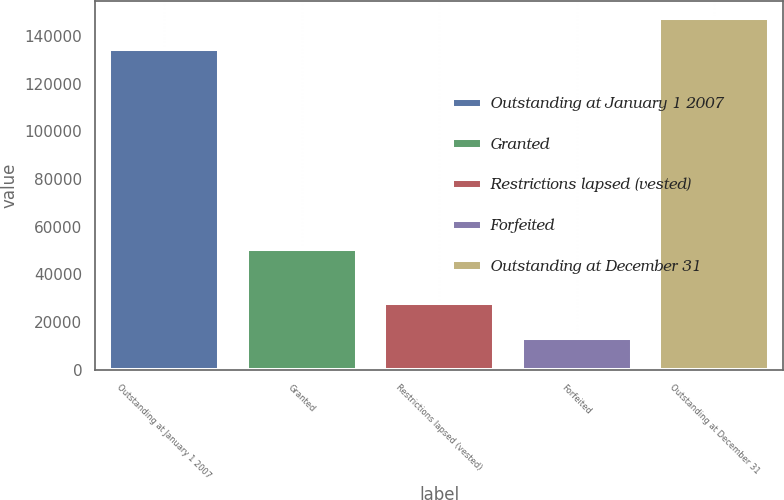Convert chart. <chart><loc_0><loc_0><loc_500><loc_500><bar_chart><fcel>Outstanding at January 1 2007<fcel>Granted<fcel>Restrictions lapsed (vested)<fcel>Forfeited<fcel>Outstanding at December 31<nl><fcel>134378<fcel>50509<fcel>28044<fcel>13234<fcel>147416<nl></chart> 